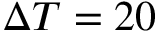<formula> <loc_0><loc_0><loc_500><loc_500>\Delta T = 2 0</formula> 